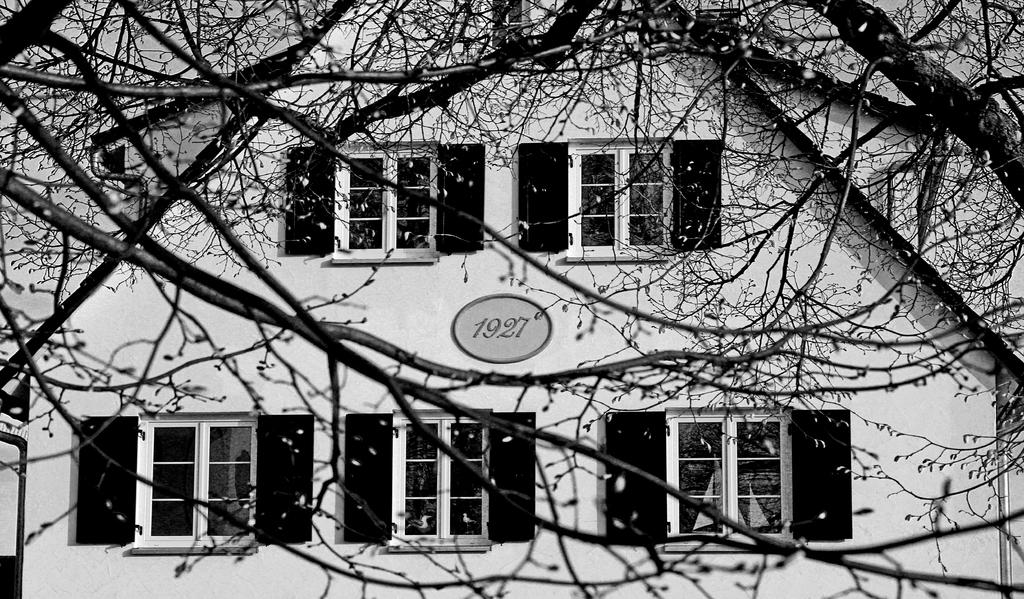What type of structure is present in the image? There is a building in the image. What feature can be seen on the building? The building has windows. What can be seen in the background of the image? There are trees visible in the image. What object with numbers is present in the image? There is a board with numbers in the image. Where is the dad in the image? There is no dad present in the image. What type of floor is visible in the image? The image does not show the floor, so it cannot be determined from the image. 